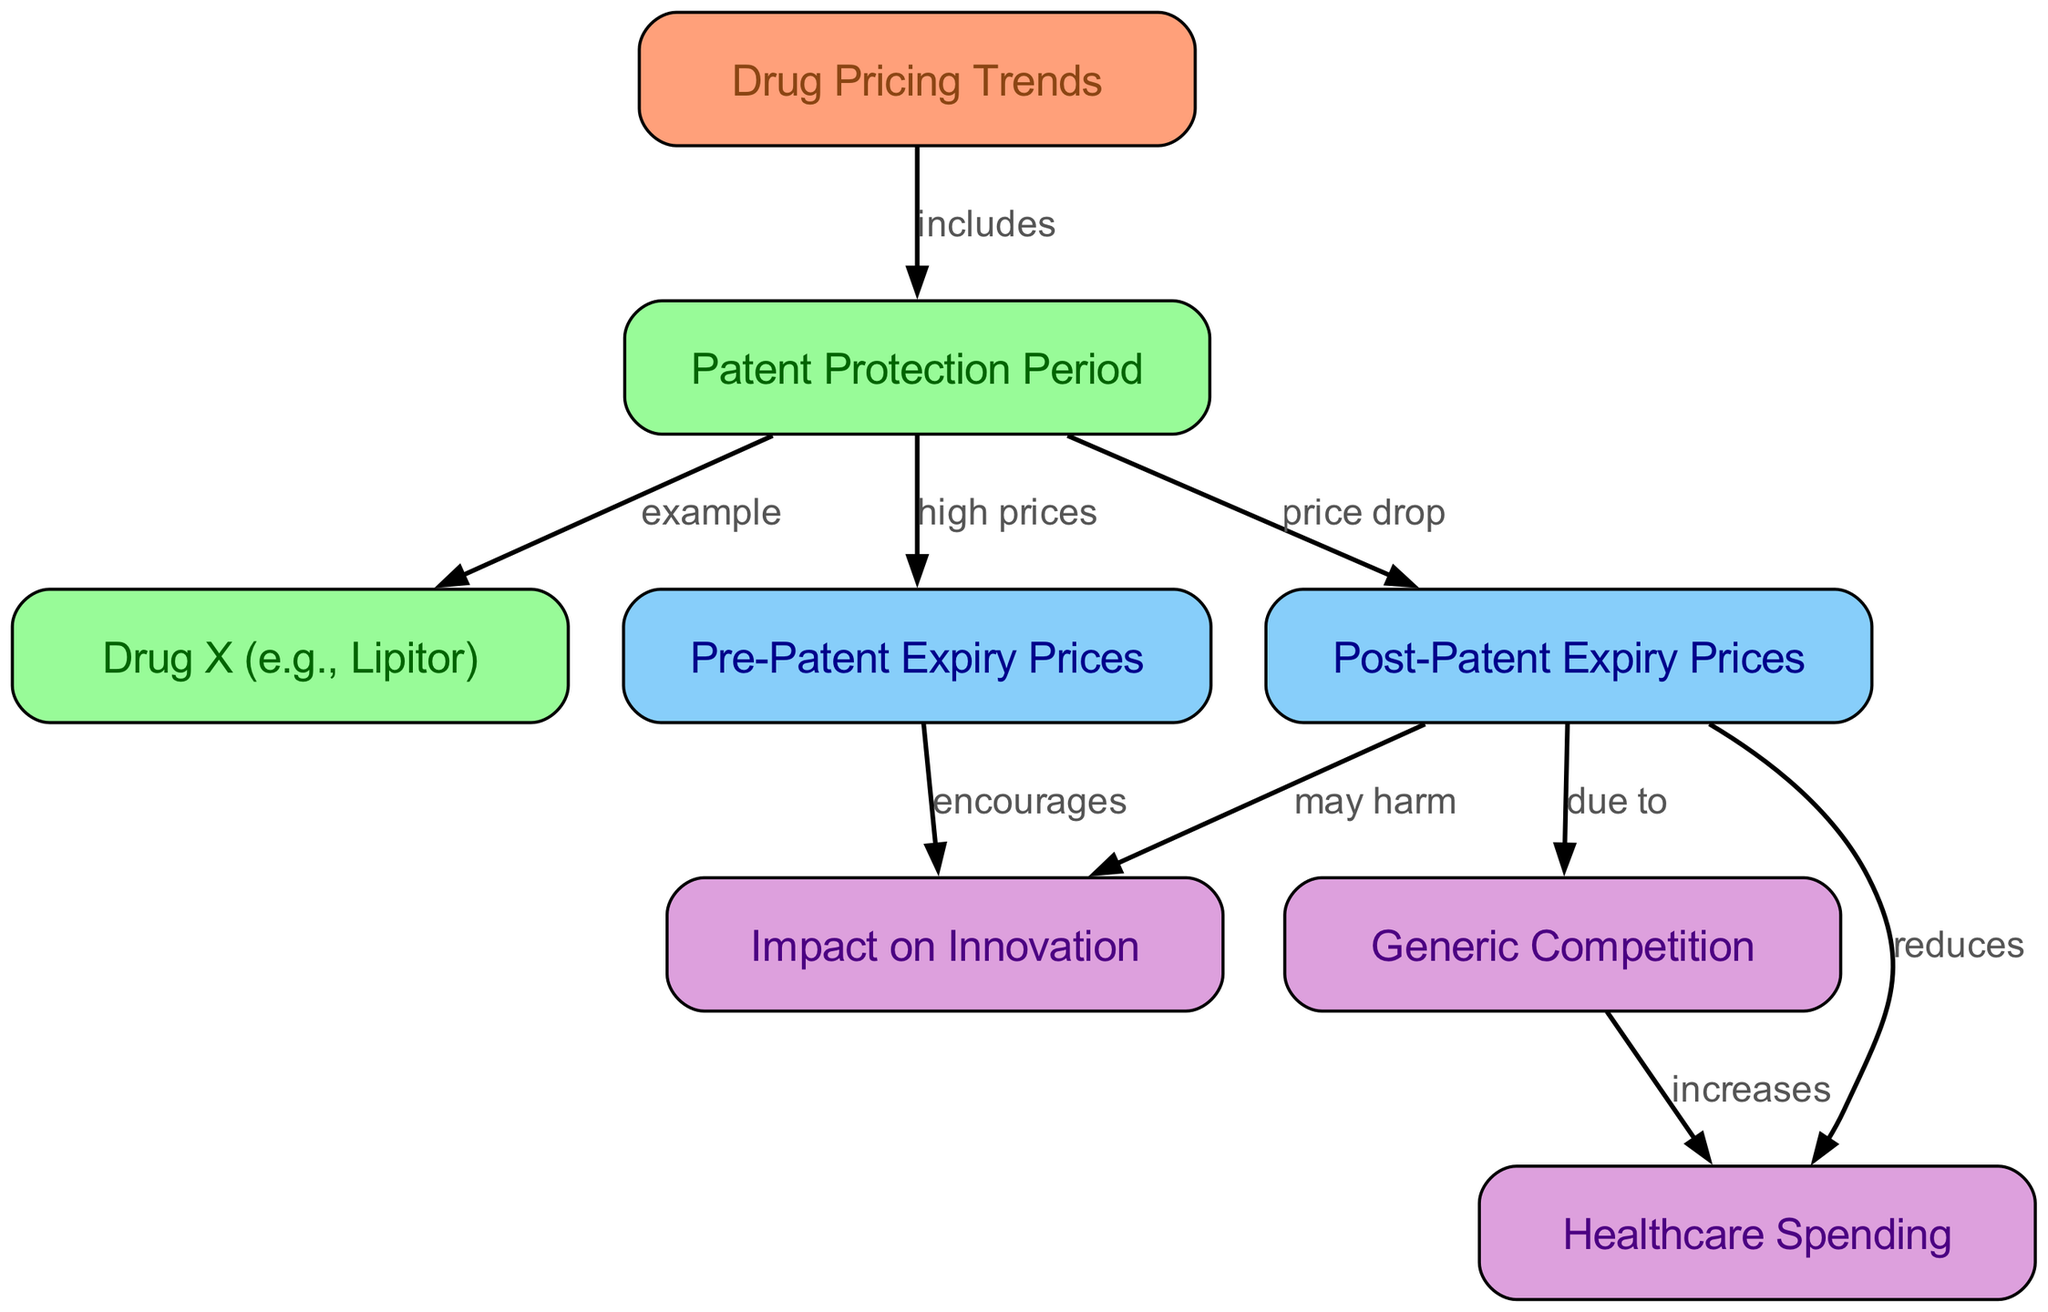What is the main subject of the diagram? The diagram centers around "Drug Pricing Trends," indicating that it visually represents various aspects related to the pricing of drugs before and after patent expiration.
Answer: Drug Pricing Trends Which drug is provided as an example in the diagram? The diagram specifically mentions "Drug X (e.g., Lipitor)" to illustrate its points regarding drug pricing trends and patent protection.
Answer: Lipitor What happens to prices after patent expiry according to the diagram? The edge connecting "Post-Patent Expiry Prices" indicates that there is a "price drop" following the expiration of a patent, suggesting a significant reduction in drug prices due to generic options.
Answer: price drop How does the patent protection period relate to pre-patent expiry prices? The diagram shows an edge labeled "high prices" connecting "Patent Protection Period" to "Pre-Patent Expiry Prices," indicating that during the patent protection period, drug prices are generally high.
Answer: high prices What effect does post-patent expiry pricing have on healthcare spending? The diagram indicates a connection where "Post-Patent Expiry Prices" "reduces" "Healthcare Spending," suggesting that lower prices after patent expiration lead to decreased overall spending in the healthcare sector.
Answer: reduces What is the impact of generic competition on healthcare spending? A connection between "Generic Competition" and "Healthcare Spending" shows that generic competition "increases" healthcare spending, which may imply that competition helps enhance access to medications and thus increases healthcare utilization.
Answer: increases How does pre-patent expiry pricing affect innovation? There is a connection from "Pre-Patent Expiry Prices" to "Impact on Innovation," labeled as "encourages," suggesting that high prices before patent expiration may incentivize innovation in the pharmaceutical industry by allowing companies to recoup research and development costs.
Answer: encourages What may be a negative impact of post-patent expiry pricing on innovation? The diagram notes that "Post-Patent Expiry Prices" "may harm" "Impact on Innovation," indicating a potential downside where lower prices after patent expiration could disincentivize future pharmaceutical innovations.
Answer: may harm 